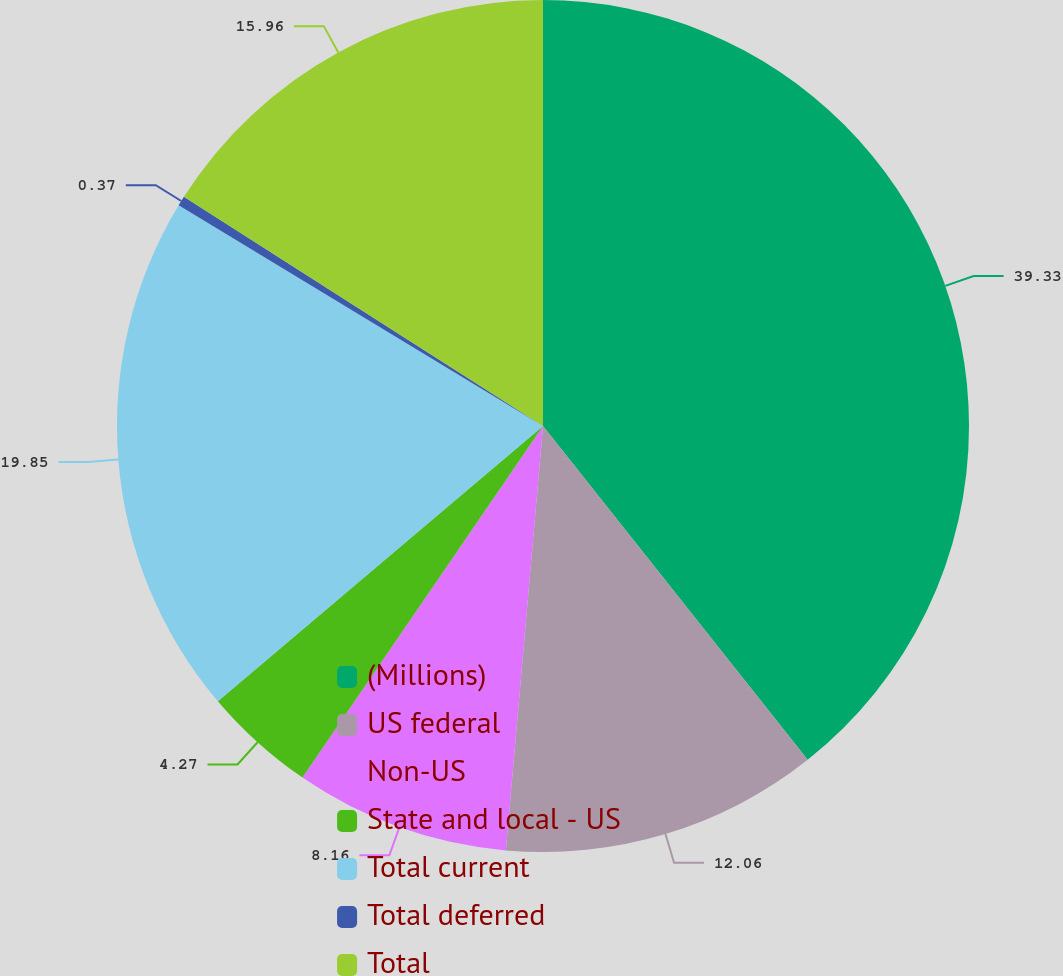Convert chart. <chart><loc_0><loc_0><loc_500><loc_500><pie_chart><fcel>(Millions)<fcel>US federal<fcel>Non-US<fcel>State and local - US<fcel>Total current<fcel>Total deferred<fcel>Total<nl><fcel>39.33%<fcel>12.06%<fcel>8.16%<fcel>4.27%<fcel>19.85%<fcel>0.37%<fcel>15.96%<nl></chart> 